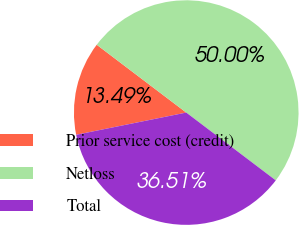<chart> <loc_0><loc_0><loc_500><loc_500><pie_chart><fcel>Prior service cost (credit)<fcel>Netloss<fcel>Total<nl><fcel>13.49%<fcel>50.0%<fcel>36.51%<nl></chart> 